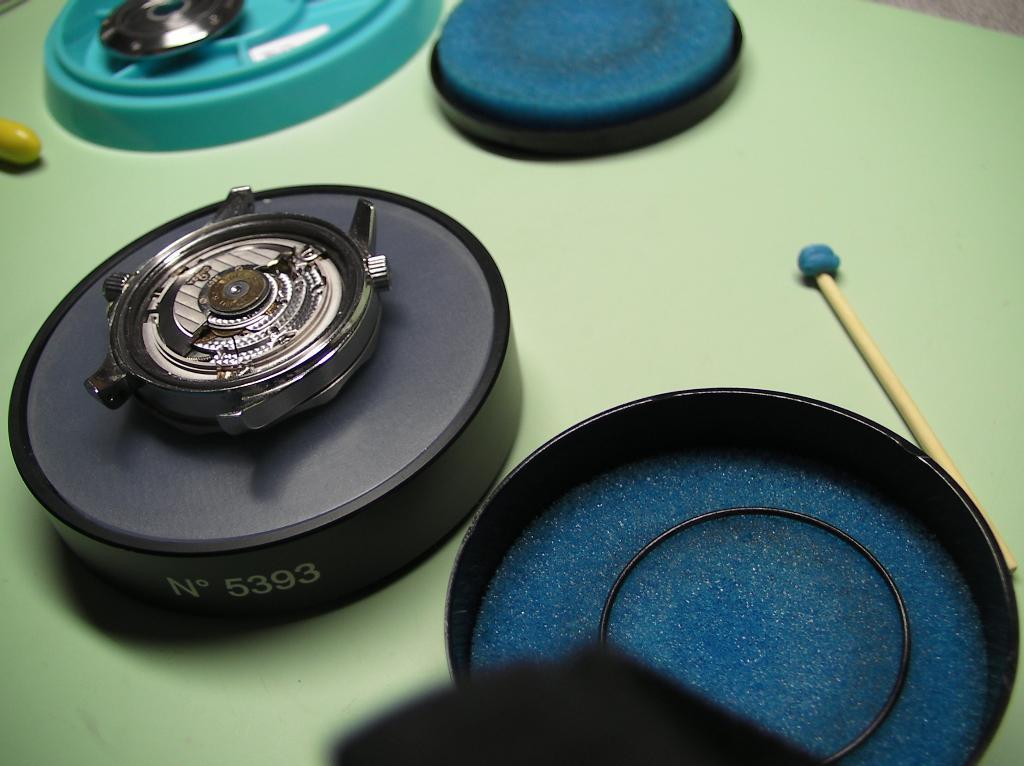In one or two sentences, can you explain what this image depicts? In this image we can see the camera lens, and some other objects on the green color surface. 